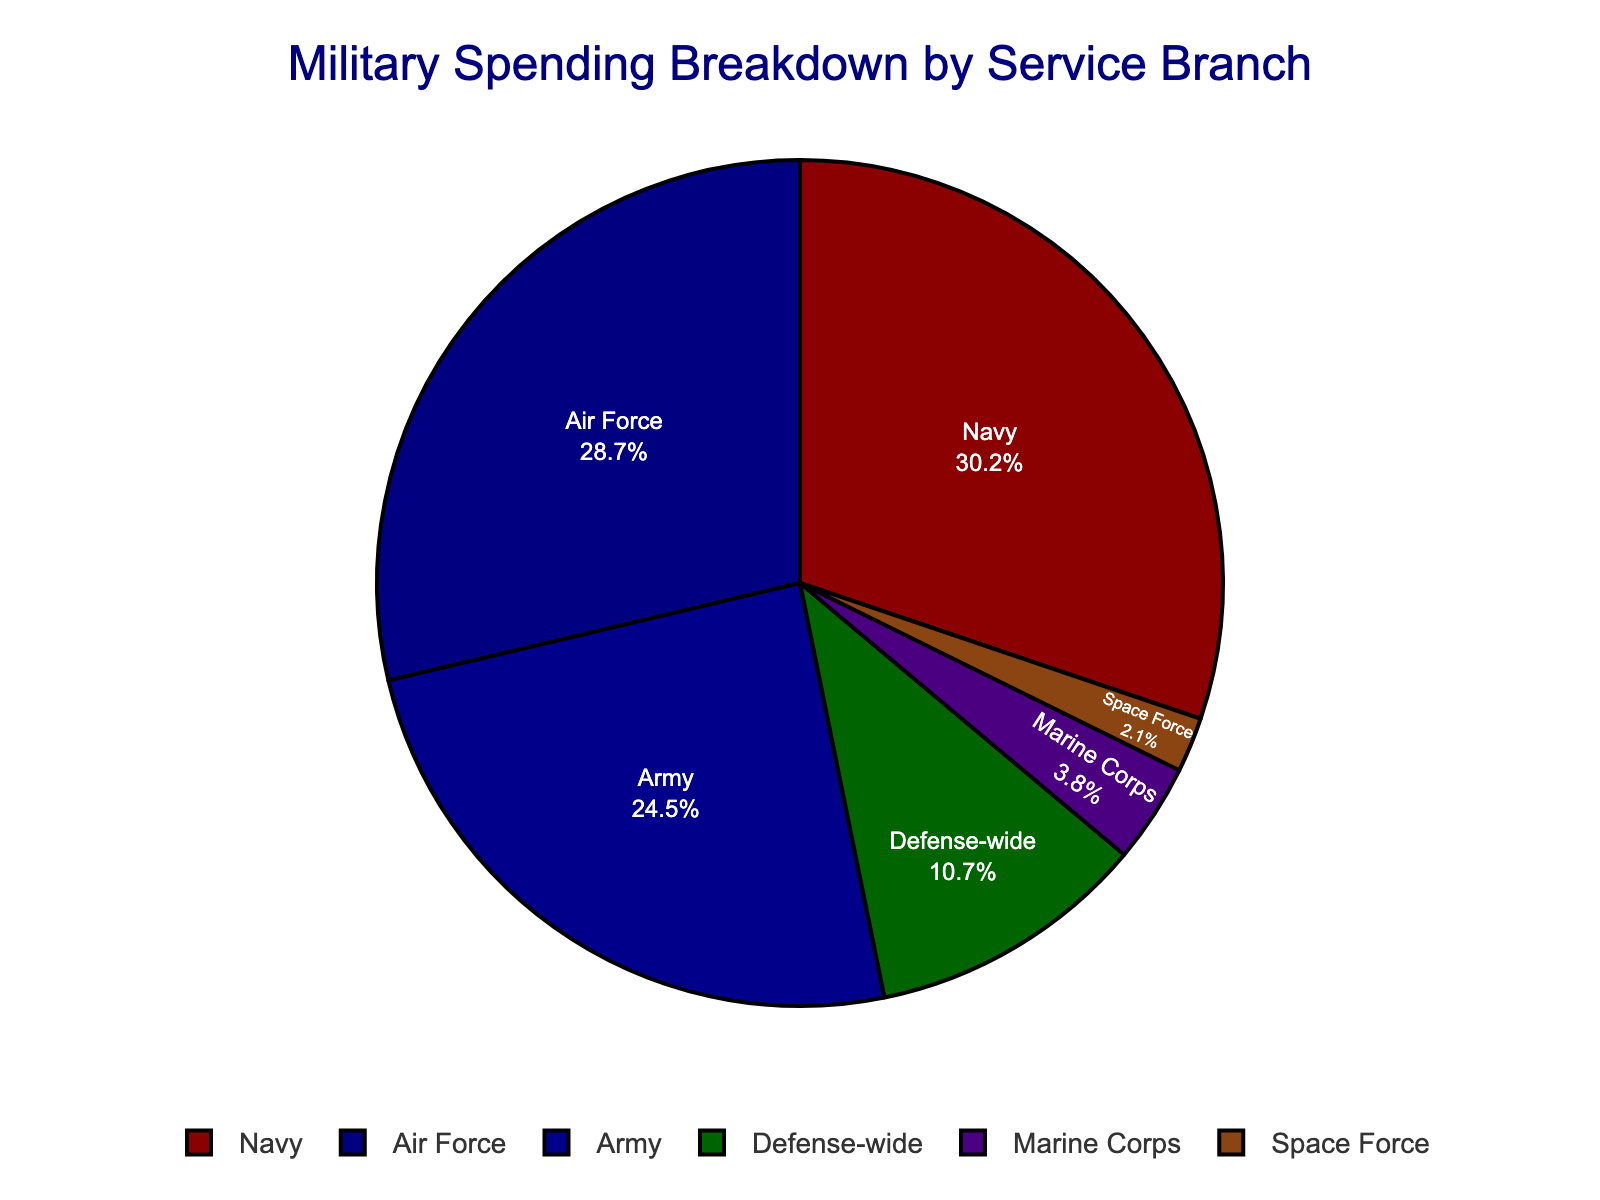Which military branch receives the highest percentage of spending? The figure shows the breakdown of spending percentages for each military branch. The Navy receives the highest percentage of spending at 30.2%.
Answer: Navy Which branch gets the least amount of military spending? The figure shows the breakdown of spending percentages for each military branch. The Space Force gets the least amount of military spending at 2.1%.
Answer: Space Force How much more is the Navy's spending compared to the Marine Corps? The Navy's spending is 30.2% and the Marine Corps' is 3.8%. The difference is 30.2% - 3.8% = 26.4%.
Answer: 26.4% What is the combined spending percentage for the Army and the Air Force? The Army's spending is 24.5% and the Air Force's is 28.7%. The combined percentage is 24.5% + 28.7% = 53.2%.
Answer: 53.2% How does the spending on the Defense-wide category compare to that of the Space Force? The Defense-wide category gets 10.7% whereas the Space Force gets 2.1%. The Defense-wide category gets 10.7% - 2.1% = 8.6% more.
Answer: 8.6% more Which two branches have the closest spending percentages? By examining the figure, the Army (24.5%) and the Air Force (28.7%) have the closest spending percentages with a difference of 28.7% - 24.5% = 4.2%.
Answer: Army and Air Force What's the total percentage of spending allocated to branches other than the Army, Navy, and Air Force? The branches other than the Army, Navy, and Air Force are the Marine Corps, Space Force, and Defense-wide. Their combined spending percentage is 3.8% + 2.1% + 10.7% = 16.6%.
Answer: 16.6% Is the funding for the Marine Corps greater than 5%? The figure shows that the Marine Corps receives 3.8% of military spending, which is less than 5%.
Answer: No What is the color used to represent the Army in the pie chart? By examining the figure, the color red is used to represent the Army.
Answer: Red Which branches together make up more than half of the total military spending? By adding the percentages of different branches, the Army (24.5%) and the Air Force (28.7%) together sum up to 24.5% + 28.7% = 53.2%. They make up more than half of the total military spending.
Answer: Army and Air Force 